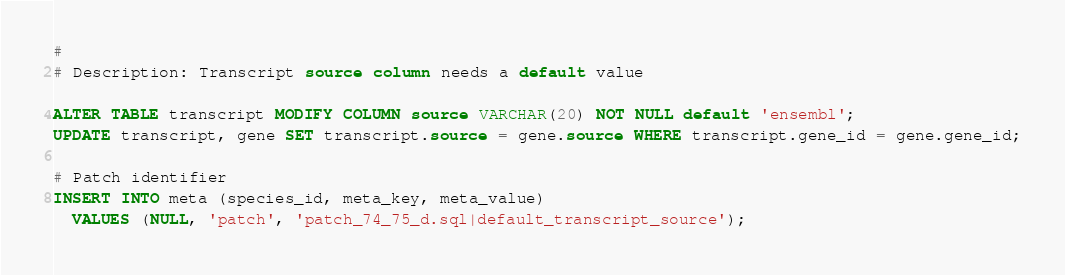Convert code to text. <code><loc_0><loc_0><loc_500><loc_500><_SQL_>#
# Description: Transcript source column needs a default value

ALTER TABLE transcript MODIFY COLUMN source VARCHAR(20) NOT NULL default 'ensembl';
UPDATE transcript, gene SET transcript.source = gene.source WHERE transcript.gene_id = gene.gene_id;

# Patch identifier
INSERT INTO meta (species_id, meta_key, meta_value)
  VALUES (NULL, 'patch', 'patch_74_75_d.sql|default_transcript_source');


</code> 